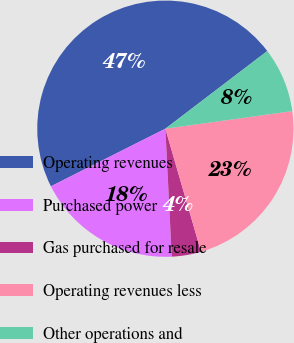Convert chart. <chart><loc_0><loc_0><loc_500><loc_500><pie_chart><fcel>Operating revenues<fcel>Purchased power<fcel>Gas purchased for resale<fcel>Operating revenues less<fcel>Other operations and<nl><fcel>47.06%<fcel>18.37%<fcel>3.7%<fcel>22.7%<fcel>8.17%<nl></chart> 